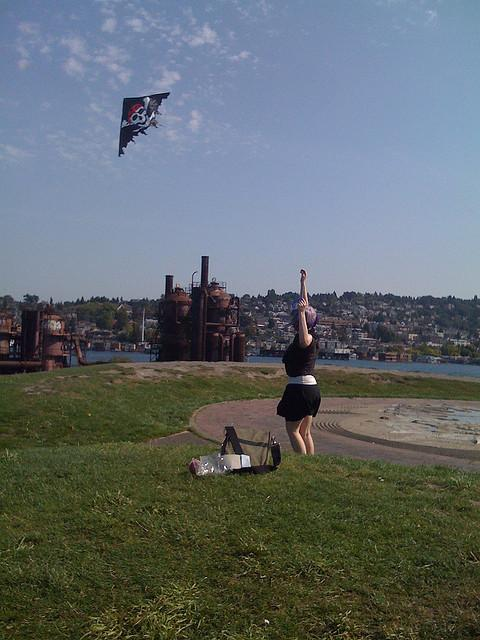How does the woman direct here kite and control it? string 